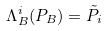<formula> <loc_0><loc_0><loc_500><loc_500>\Lambda _ { B } ^ { i } ( P _ { B } ) = \tilde { P } _ { i }</formula> 